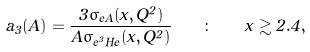Convert formula to latex. <formula><loc_0><loc_0><loc_500><loc_500>a _ { 3 } ( A ) = \frac { 3 \sigma _ { e A } ( x , Q ^ { 2 } ) } { A \sigma _ { e ^ { 3 } H e } ( x , Q ^ { 2 } ) } \quad \colon \quad x \gtrsim 2 . 4 ,</formula> 